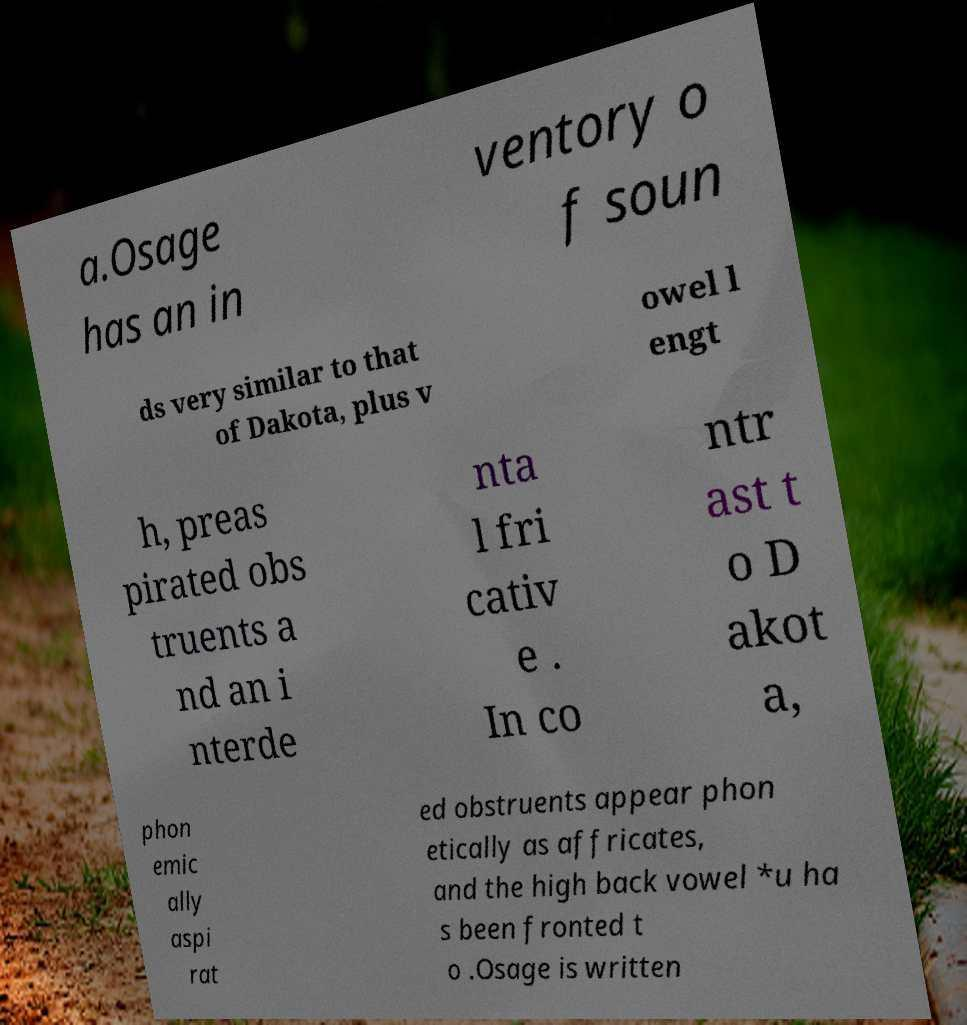What messages or text are displayed in this image? I need them in a readable, typed format. a.Osage has an in ventory o f soun ds very similar to that of Dakota, plus v owel l engt h, preas pirated obs truents a nd an i nterde nta l fri cativ e . In co ntr ast t o D akot a, phon emic ally aspi rat ed obstruents appear phon etically as affricates, and the high back vowel *u ha s been fronted t o .Osage is written 